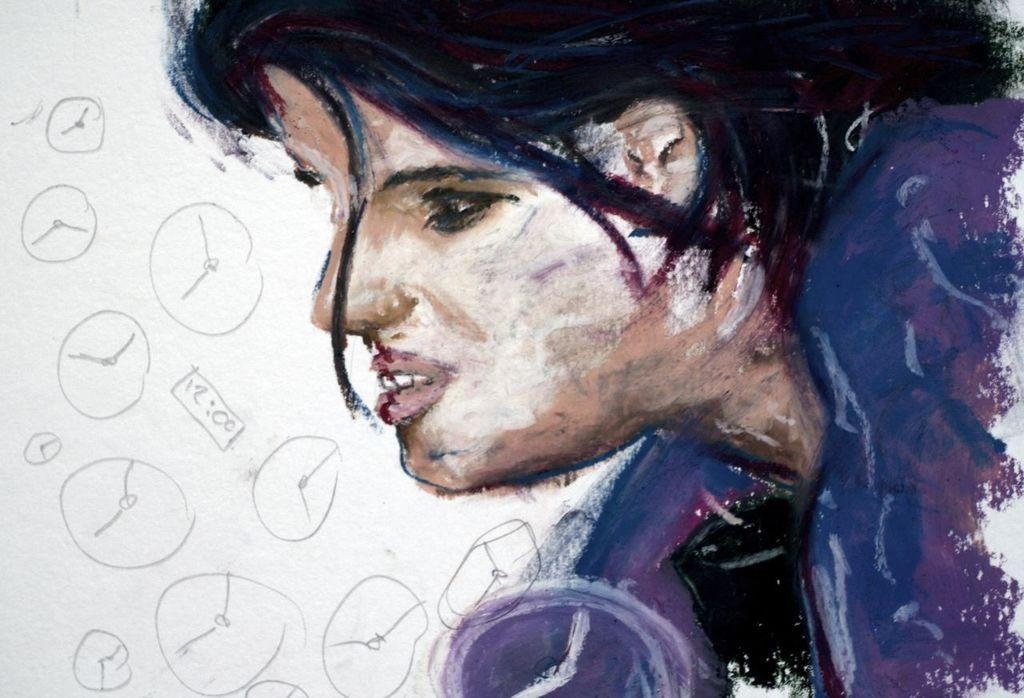What is depicted in the painting in the image? There is a painting of a person in the image. What can be observed about the colors used in the painting? The painting has multicolor elements. What color is the background of the painting? The background of the painting is white. Are there any words or letters in the painting? Yes, there is text written on the background of the painting. How many pins can be seen attached to the person's arm in the painting? There are no pins visible in the painting; it only features a person and text on a white background. 